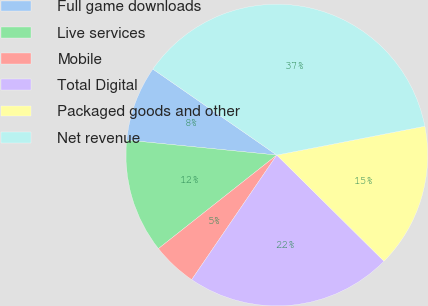Convert chart. <chart><loc_0><loc_0><loc_500><loc_500><pie_chart><fcel>Full game downloads<fcel>Live services<fcel>Mobile<fcel>Total Digital<fcel>Packaged goods and other<fcel>Net revenue<nl><fcel>8.07%<fcel>12.23%<fcel>4.82%<fcel>22.12%<fcel>15.48%<fcel>37.29%<nl></chart> 